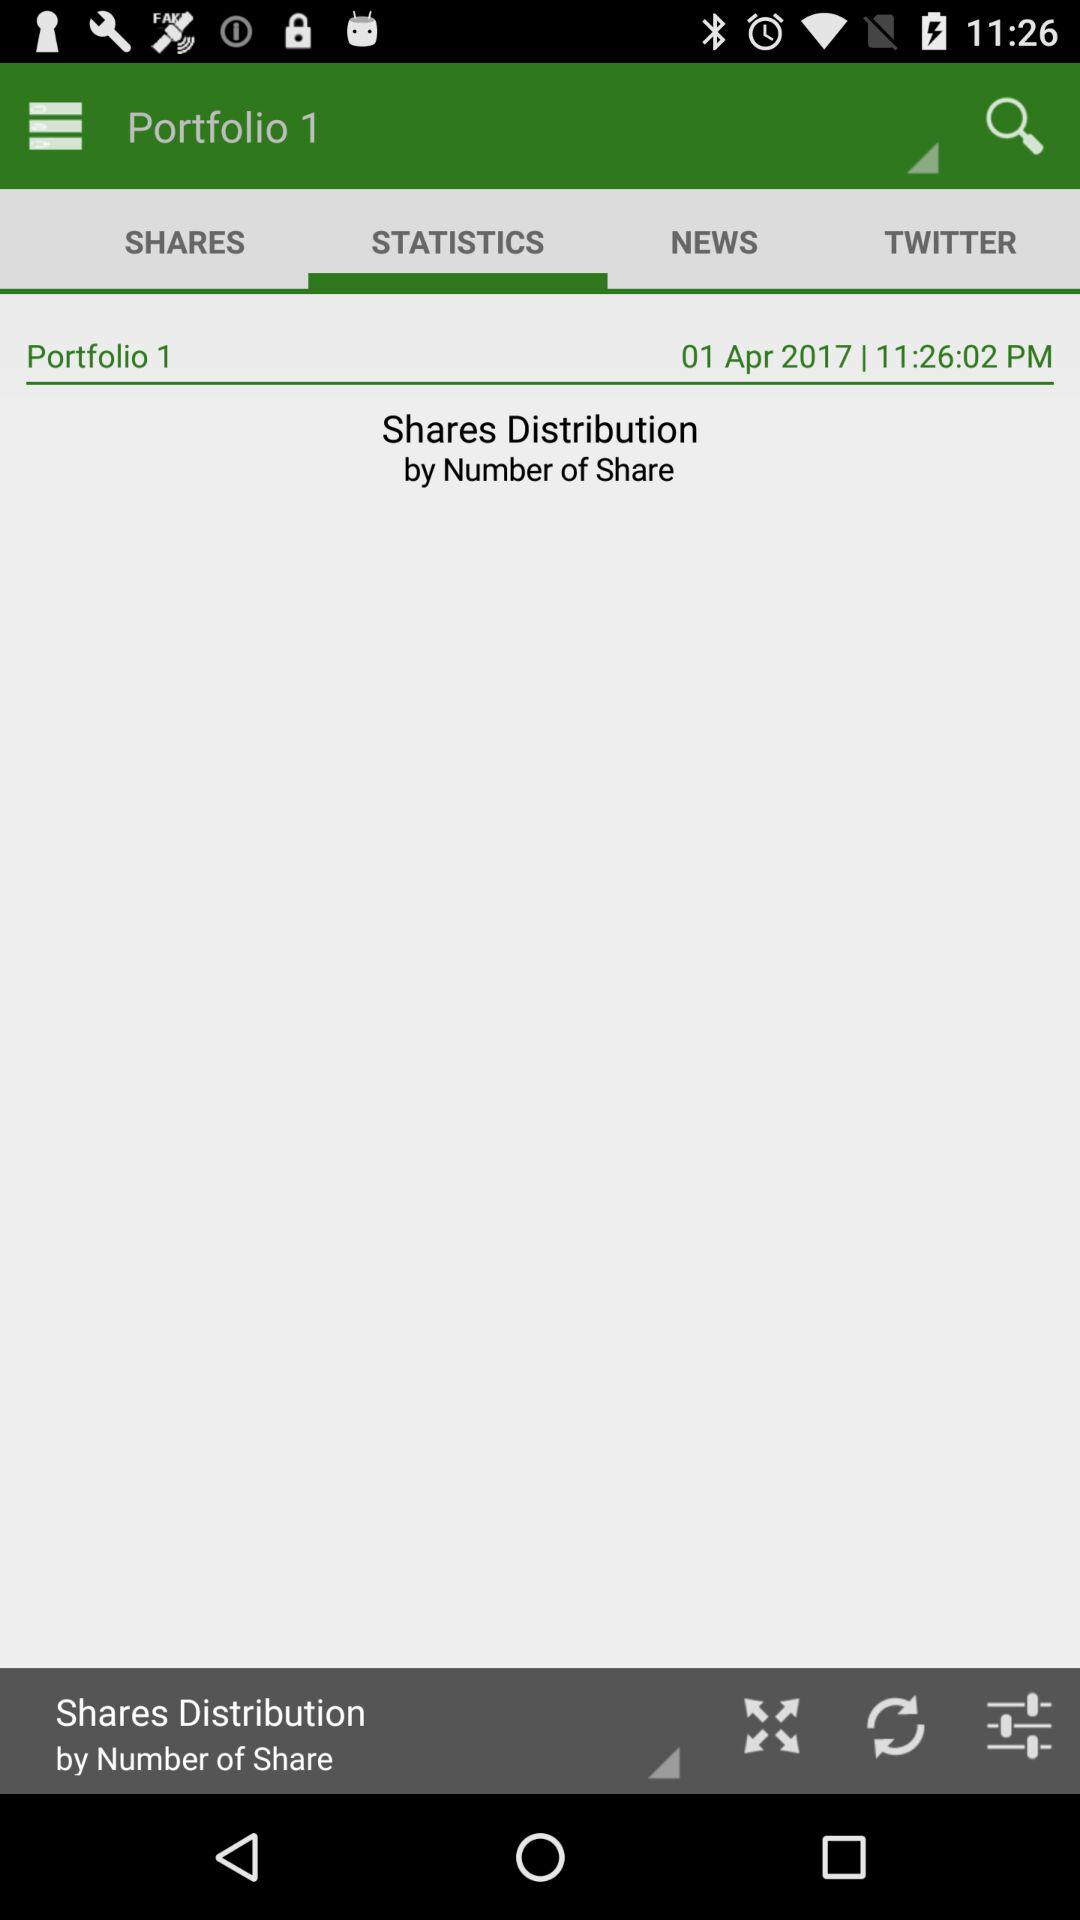Which option is selected in "Portfolio 1"? The selected option in "Portfolio 1" is "STATISTICS". 